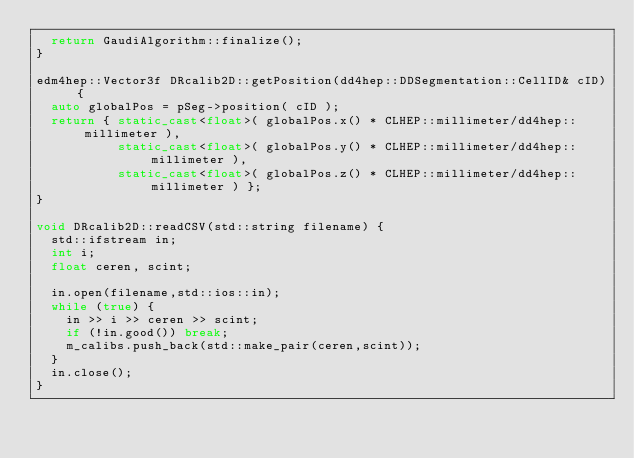Convert code to text. <code><loc_0><loc_0><loc_500><loc_500><_C++_>  return GaudiAlgorithm::finalize();
}

edm4hep::Vector3f DRcalib2D::getPosition(dd4hep::DDSegmentation::CellID& cID) {
  auto globalPos = pSeg->position( cID );
  return { static_cast<float>( globalPos.x() * CLHEP::millimeter/dd4hep::millimeter ),
           static_cast<float>( globalPos.y() * CLHEP::millimeter/dd4hep::millimeter ),
           static_cast<float>( globalPos.z() * CLHEP::millimeter/dd4hep::millimeter ) };
}

void DRcalib2D::readCSV(std::string filename) {
  std::ifstream in;
  int i;
  float ceren, scint;

  in.open(filename,std::ios::in);
  while (true) {
    in >> i >> ceren >> scint;
    if (!in.good()) break;
    m_calibs.push_back(std::make_pair(ceren,scint));
  }
  in.close();
}
</code> 